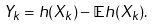<formula> <loc_0><loc_0><loc_500><loc_500>Y _ { k } = h ( X _ { k } ) - { \mathbb { E } } h ( X _ { k } ) .</formula> 